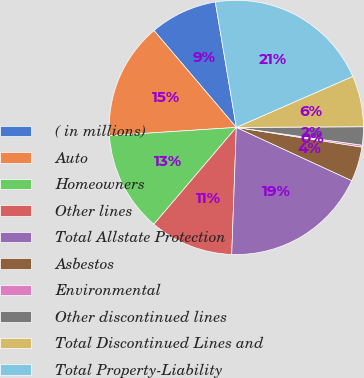Convert chart to OTSL. <chart><loc_0><loc_0><loc_500><loc_500><pie_chart><fcel>( in millions)<fcel>Auto<fcel>Homeowners<fcel>Other lines<fcel>Total Allstate Protection<fcel>Asbestos<fcel>Environmental<fcel>Other discontinued lines<fcel>Total Discontinued Lines and<fcel>Total Property-Liability<nl><fcel>8.57%<fcel>14.82%<fcel>12.74%<fcel>10.65%<fcel>18.7%<fcel>4.4%<fcel>0.24%<fcel>2.32%<fcel>6.49%<fcel>21.07%<nl></chart> 